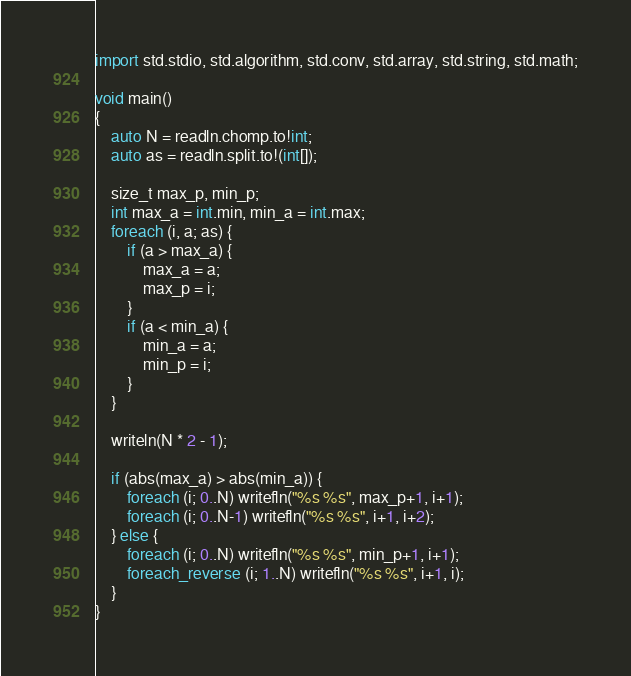Convert code to text. <code><loc_0><loc_0><loc_500><loc_500><_D_>import std.stdio, std.algorithm, std.conv, std.array, std.string, std.math;

void main()
{
    auto N = readln.chomp.to!int;
    auto as = readln.split.to!(int[]);

    size_t max_p, min_p;
    int max_a = int.min, min_a = int.max;
    foreach (i, a; as) {
        if (a > max_a) {
            max_a = a;
            max_p = i;
        }
        if (a < min_a) {
            min_a = a;
            min_p = i;
        }
    }

    writeln(N * 2 - 1);

    if (abs(max_a) > abs(min_a)) {
        foreach (i; 0..N) writefln("%s %s", max_p+1, i+1);
        foreach (i; 0..N-1) writefln("%s %s", i+1, i+2);
    } else {
        foreach (i; 0..N) writefln("%s %s", min_p+1, i+1);
        foreach_reverse (i; 1..N) writefln("%s %s", i+1, i);
    }
}</code> 